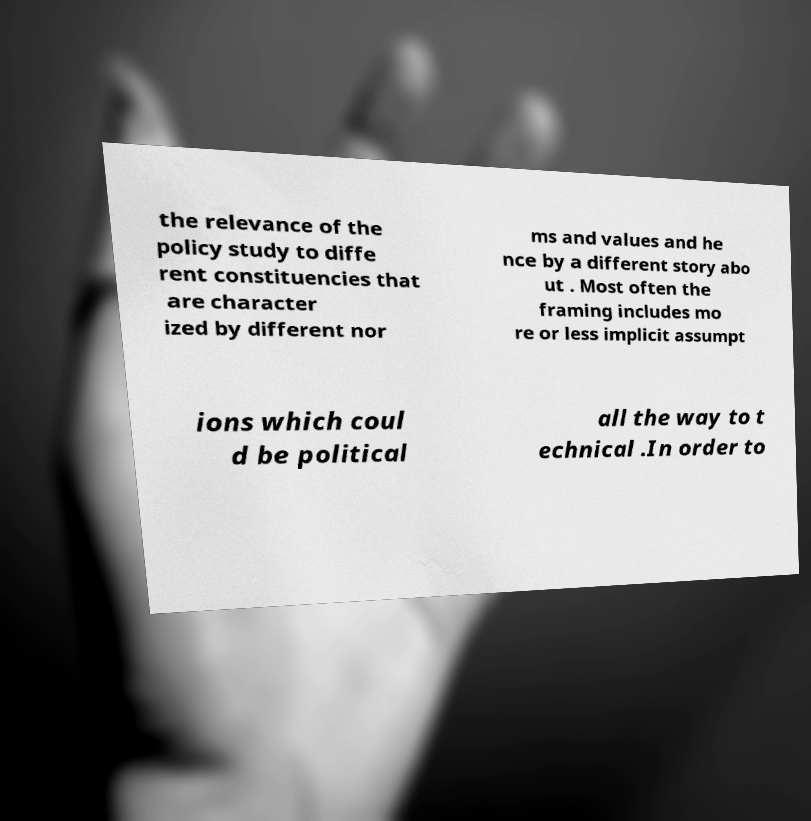Could you extract and type out the text from this image? the relevance of the policy study to diffe rent constituencies that are character ized by different nor ms and values and he nce by a different story abo ut . Most often the framing includes mo re or less implicit assumpt ions which coul d be political all the way to t echnical .In order to 